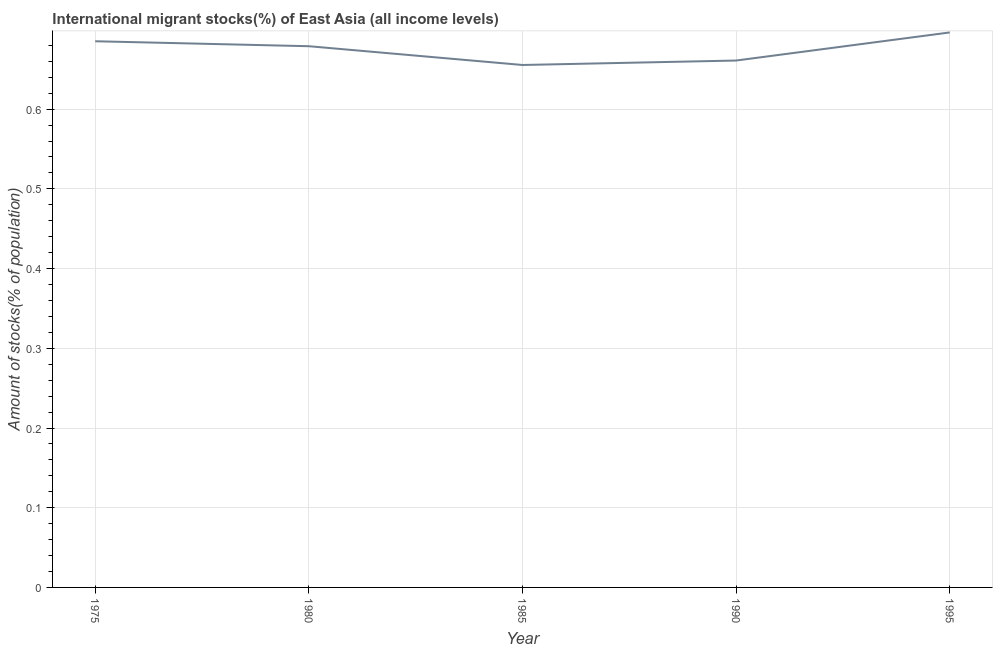What is the number of international migrant stocks in 1995?
Provide a short and direct response. 0.7. Across all years, what is the maximum number of international migrant stocks?
Provide a succinct answer. 0.7. Across all years, what is the minimum number of international migrant stocks?
Make the answer very short. 0.66. In which year was the number of international migrant stocks maximum?
Your answer should be very brief. 1995. In which year was the number of international migrant stocks minimum?
Make the answer very short. 1985. What is the sum of the number of international migrant stocks?
Ensure brevity in your answer.  3.38. What is the difference between the number of international migrant stocks in 1985 and 1995?
Your answer should be very brief. -0.04. What is the average number of international migrant stocks per year?
Your answer should be compact. 0.68. What is the median number of international migrant stocks?
Give a very brief answer. 0.68. In how many years, is the number of international migrant stocks greater than 0.6200000000000001 %?
Your answer should be compact. 5. Do a majority of the years between 1980 and 1985 (inclusive) have number of international migrant stocks greater than 0.46 %?
Provide a succinct answer. Yes. What is the ratio of the number of international migrant stocks in 1975 to that in 1980?
Ensure brevity in your answer.  1.01. What is the difference between the highest and the second highest number of international migrant stocks?
Your response must be concise. 0.01. What is the difference between the highest and the lowest number of international migrant stocks?
Ensure brevity in your answer.  0.04. In how many years, is the number of international migrant stocks greater than the average number of international migrant stocks taken over all years?
Offer a terse response. 3. Does the number of international migrant stocks monotonically increase over the years?
Provide a short and direct response. No. How many lines are there?
Offer a very short reply. 1. What is the difference between two consecutive major ticks on the Y-axis?
Offer a very short reply. 0.1. Does the graph contain grids?
Give a very brief answer. Yes. What is the title of the graph?
Ensure brevity in your answer.  International migrant stocks(%) of East Asia (all income levels). What is the label or title of the X-axis?
Your answer should be compact. Year. What is the label or title of the Y-axis?
Provide a succinct answer. Amount of stocks(% of population). What is the Amount of stocks(% of population) in 1975?
Offer a terse response. 0.69. What is the Amount of stocks(% of population) in 1980?
Your response must be concise. 0.68. What is the Amount of stocks(% of population) of 1985?
Provide a succinct answer. 0.66. What is the Amount of stocks(% of population) of 1990?
Ensure brevity in your answer.  0.66. What is the Amount of stocks(% of population) in 1995?
Keep it short and to the point. 0.7. What is the difference between the Amount of stocks(% of population) in 1975 and 1980?
Your answer should be very brief. 0.01. What is the difference between the Amount of stocks(% of population) in 1975 and 1985?
Offer a terse response. 0.03. What is the difference between the Amount of stocks(% of population) in 1975 and 1990?
Your response must be concise. 0.02. What is the difference between the Amount of stocks(% of population) in 1975 and 1995?
Provide a succinct answer. -0.01. What is the difference between the Amount of stocks(% of population) in 1980 and 1985?
Make the answer very short. 0.02. What is the difference between the Amount of stocks(% of population) in 1980 and 1990?
Keep it short and to the point. 0.02. What is the difference between the Amount of stocks(% of population) in 1980 and 1995?
Offer a terse response. -0.02. What is the difference between the Amount of stocks(% of population) in 1985 and 1990?
Offer a terse response. -0.01. What is the difference between the Amount of stocks(% of population) in 1985 and 1995?
Your answer should be compact. -0.04. What is the difference between the Amount of stocks(% of population) in 1990 and 1995?
Your answer should be compact. -0.04. What is the ratio of the Amount of stocks(% of population) in 1975 to that in 1980?
Provide a succinct answer. 1.01. What is the ratio of the Amount of stocks(% of population) in 1975 to that in 1985?
Your answer should be compact. 1.04. What is the ratio of the Amount of stocks(% of population) in 1975 to that in 1990?
Give a very brief answer. 1.04. What is the ratio of the Amount of stocks(% of population) in 1980 to that in 1985?
Make the answer very short. 1.04. What is the ratio of the Amount of stocks(% of population) in 1980 to that in 1990?
Ensure brevity in your answer.  1.03. What is the ratio of the Amount of stocks(% of population) in 1980 to that in 1995?
Your response must be concise. 0.97. What is the ratio of the Amount of stocks(% of population) in 1985 to that in 1995?
Ensure brevity in your answer.  0.94. What is the ratio of the Amount of stocks(% of population) in 1990 to that in 1995?
Offer a very short reply. 0.95. 